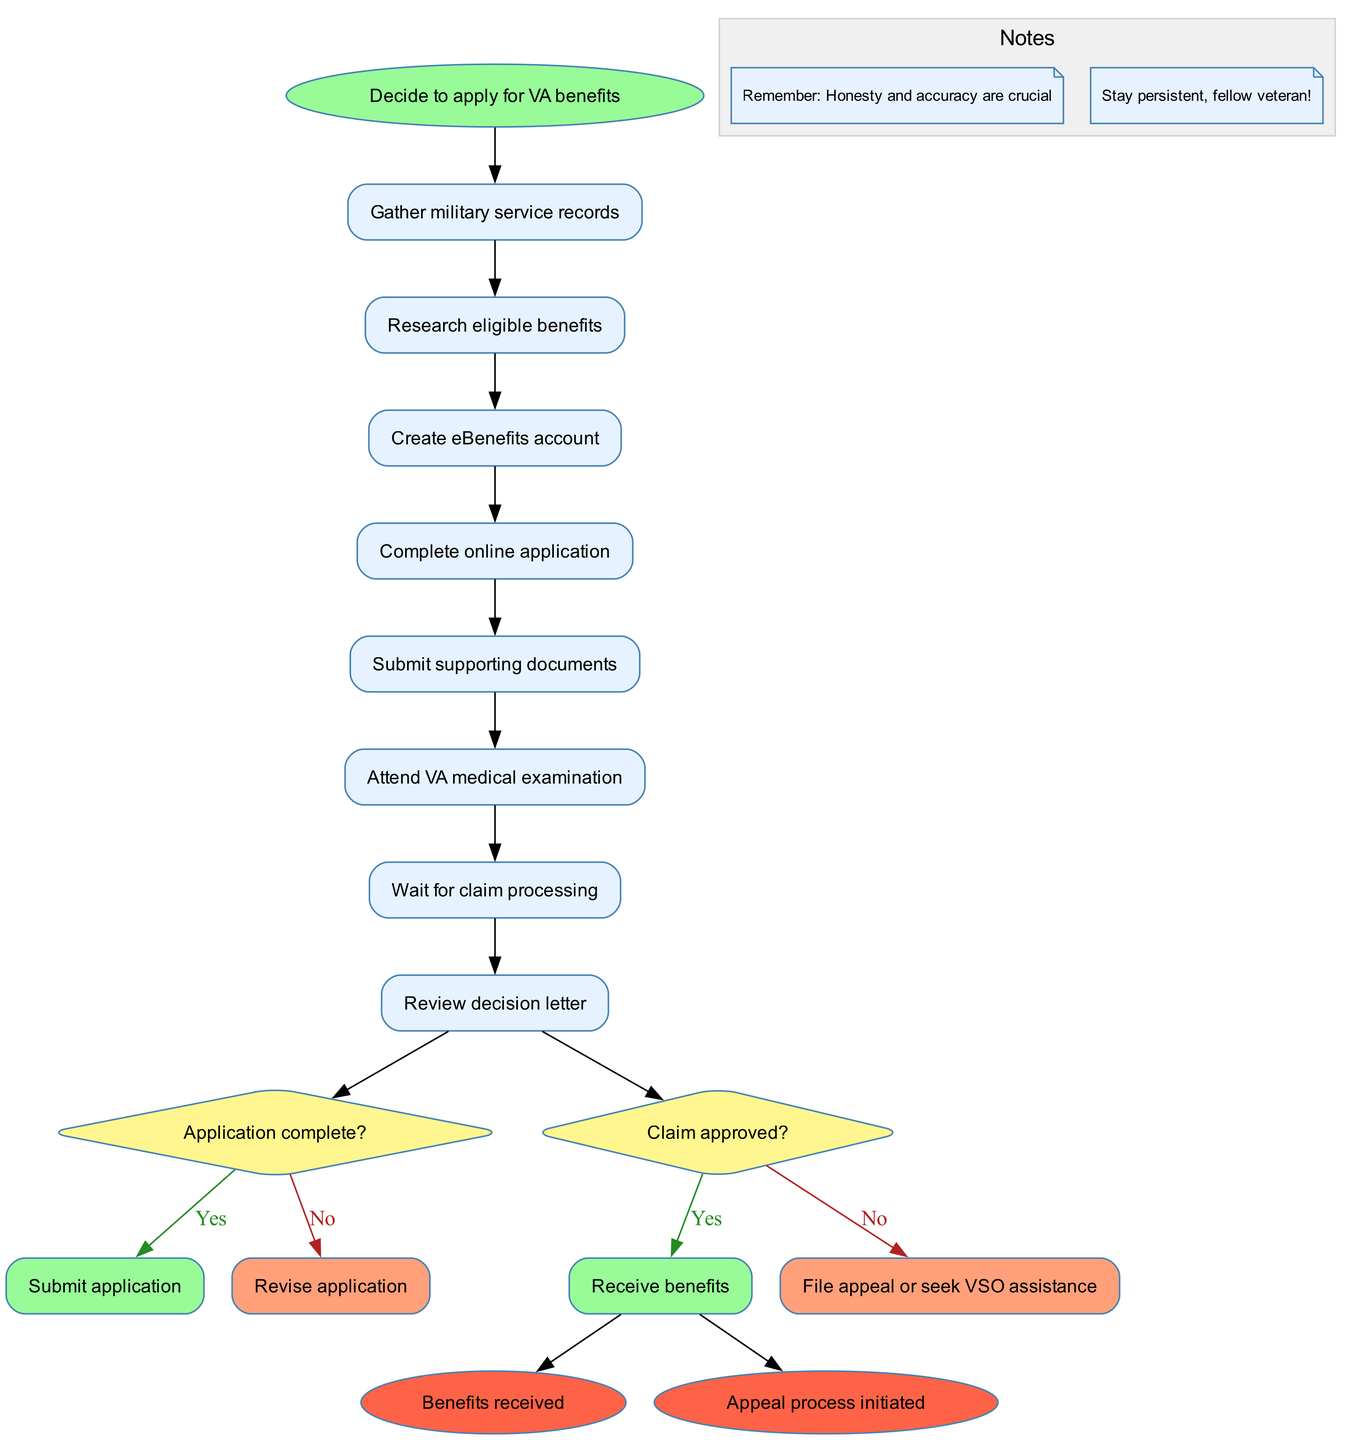What is the first activity in the workflow? The first activity in the workflow is listed under the activities section of the diagram, which starts with "Gather military service records."
Answer: Gather military service records How many activities are there in total? By counting the activities listed, we identify that there are 8 activities in the diagram.
Answer: 8 What happens after attending the VA medical examination? According to the flow of the diagram, after attending the VA medical examination, the next step is "Wait for claim processing."
Answer: Wait for claim processing What decision comes after reviewing the decision letter? After the "Review decision letter," there is a decision node that asks if the "Claim approved?". This controls the flow depending on the answer.
Answer: Claim approved? If the application is incomplete, what is the next step? If the application is determined to be incomplete, the workflow indicates that the next step is to "Revise application." This flows from the decision node related to application completeness.
Answer: Revise application What are the two outcomes after the claim decision? The two possible outcomes after the claim decision are "Benefits received" and "Appeal process initiated," which are the end nodes connected to the approval decision.
Answer: Benefits received, Appeal process initiated What is listed under the notes section? The notes section contains two reminders: "Remember: Honesty and accuracy are crucial" and "Stay persistent, fellow veteran!" that serve as guidance during the application process.
Answer: Remember: Honesty and accuracy are crucial; Stay persistent, fellow veteran! How many decision points are present in the diagram? The diagram includes two distinct decision points, one regarding application completeness and the other regarding claim approval, both of which influence the workflow's trajectory.
Answer: 2 What does the diamond shape represent in this activity diagram? In an activity diagram, a diamond shape signifies a decision point where a question is posed, directing the flow based on the response (yes or no).
Answer: Decision point 